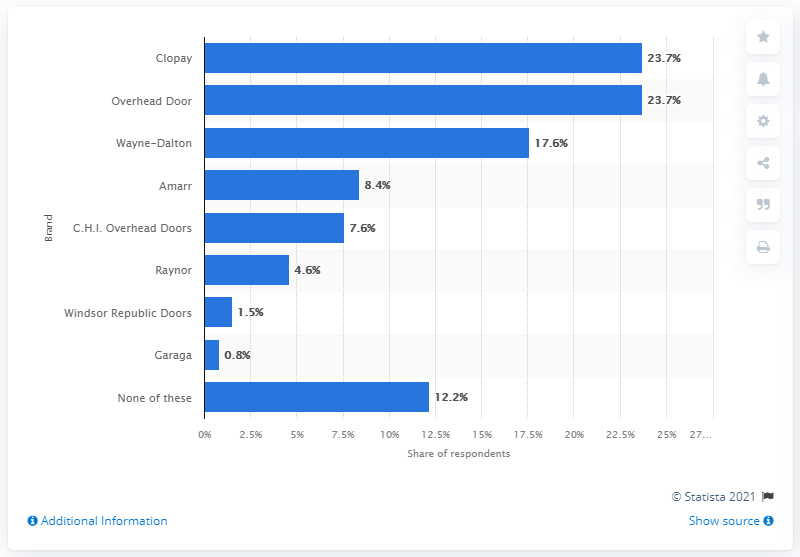Which garage door brand has the highest percentage of use according to this chart? Clopay has the highest usage at 23.7% as shown in the chart. What might explain the popularity of Clopay compared to other brands? Clopay might be more popular due to its wide range of styles, durable construction, and strong market presence, offering appealing options to consumers. 